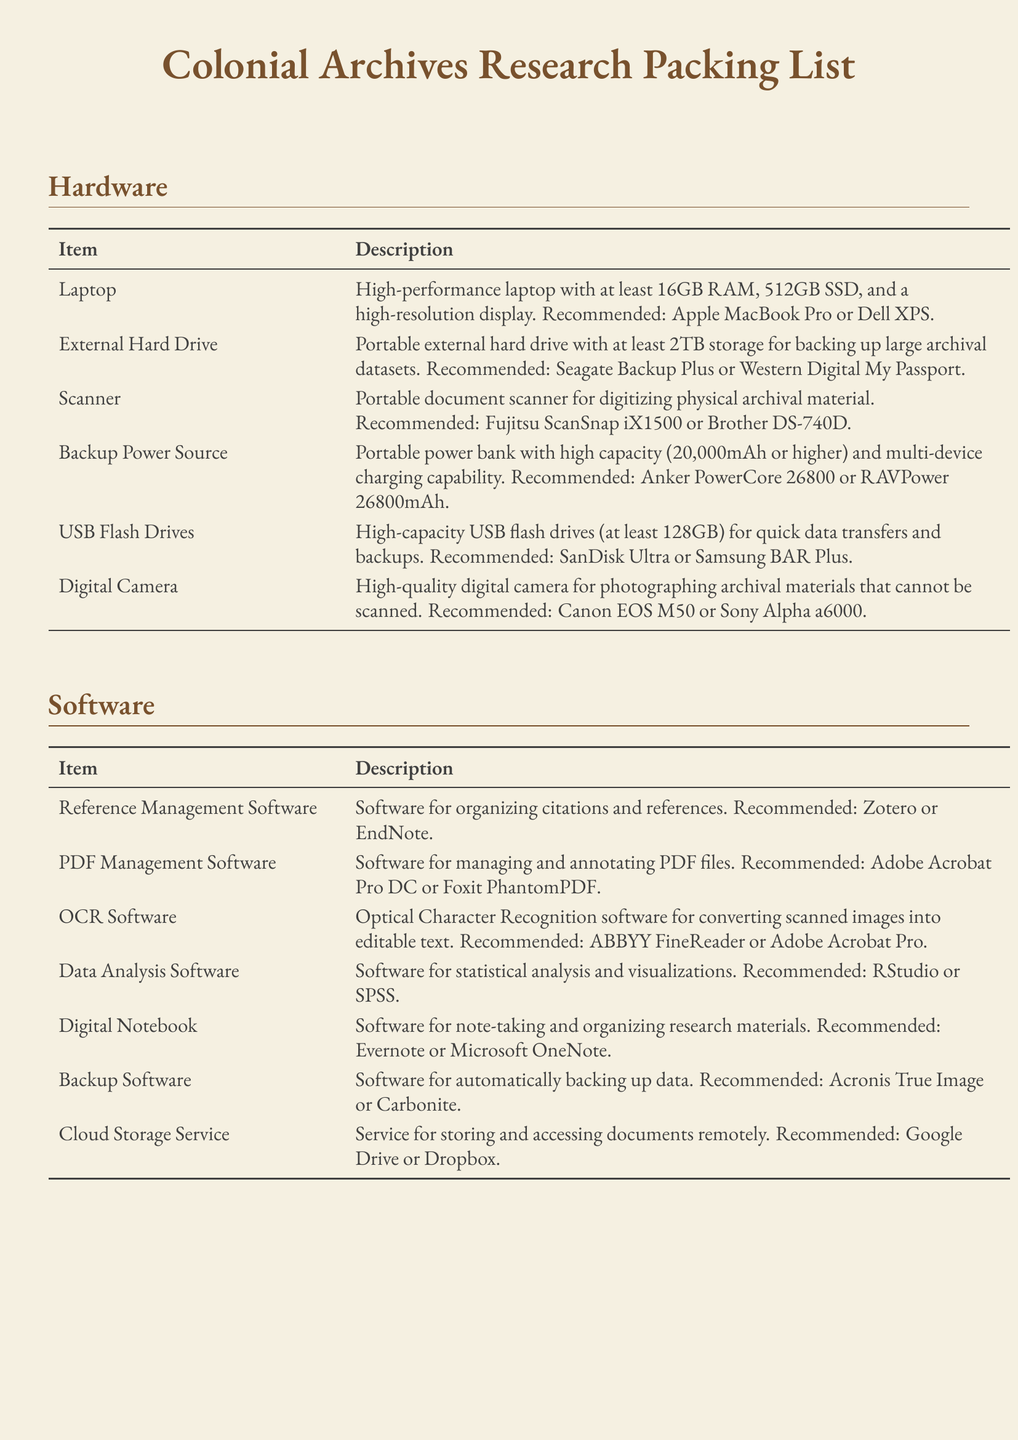What is recommended for a high-performance laptop? The document recommends either an Apple MacBook Pro or Dell XPS for a high-performance laptop.
Answer: Apple MacBook Pro or Dell XPS What storage capacity should the external hard drive have? The document states that the portable external hard drive should have at least 2TB storage.
Answer: 2TB Which software is suggested for organizing citations and references? The document recommends Zotero or EndNote for organizing citations and references.
Answer: Zotero or EndNote What is the purpose of OCR software listed in the software section? The document specifies that OCR software is for converting scanned images into editable text.
Answer: Converting scanned images into editable text What type of headphones are recommended for focused work? The document suggests noise-cancelling headphones for focused work in noisy environments.
Answer: Noise-cancelling headphones How many mAh should the backup power source have at minimum? According to the document, the minimum capacity for the backup power source should be 20,000mAh.
Answer: 20,000mAh What is a recommended digital notebook software? The document lists Evernote or Microsoft OneNote as recommended digital notebook software.
Answer: Evernote or Microsoft OneNote Which portable document scanner is mentioned in the packing list? The document mentions the Fujitsu ScanSnap iX1500 or Brother DS-740D for portable document scanning.
Answer: Fujitsu ScanSnap iX1500 or Brother DS-740D 